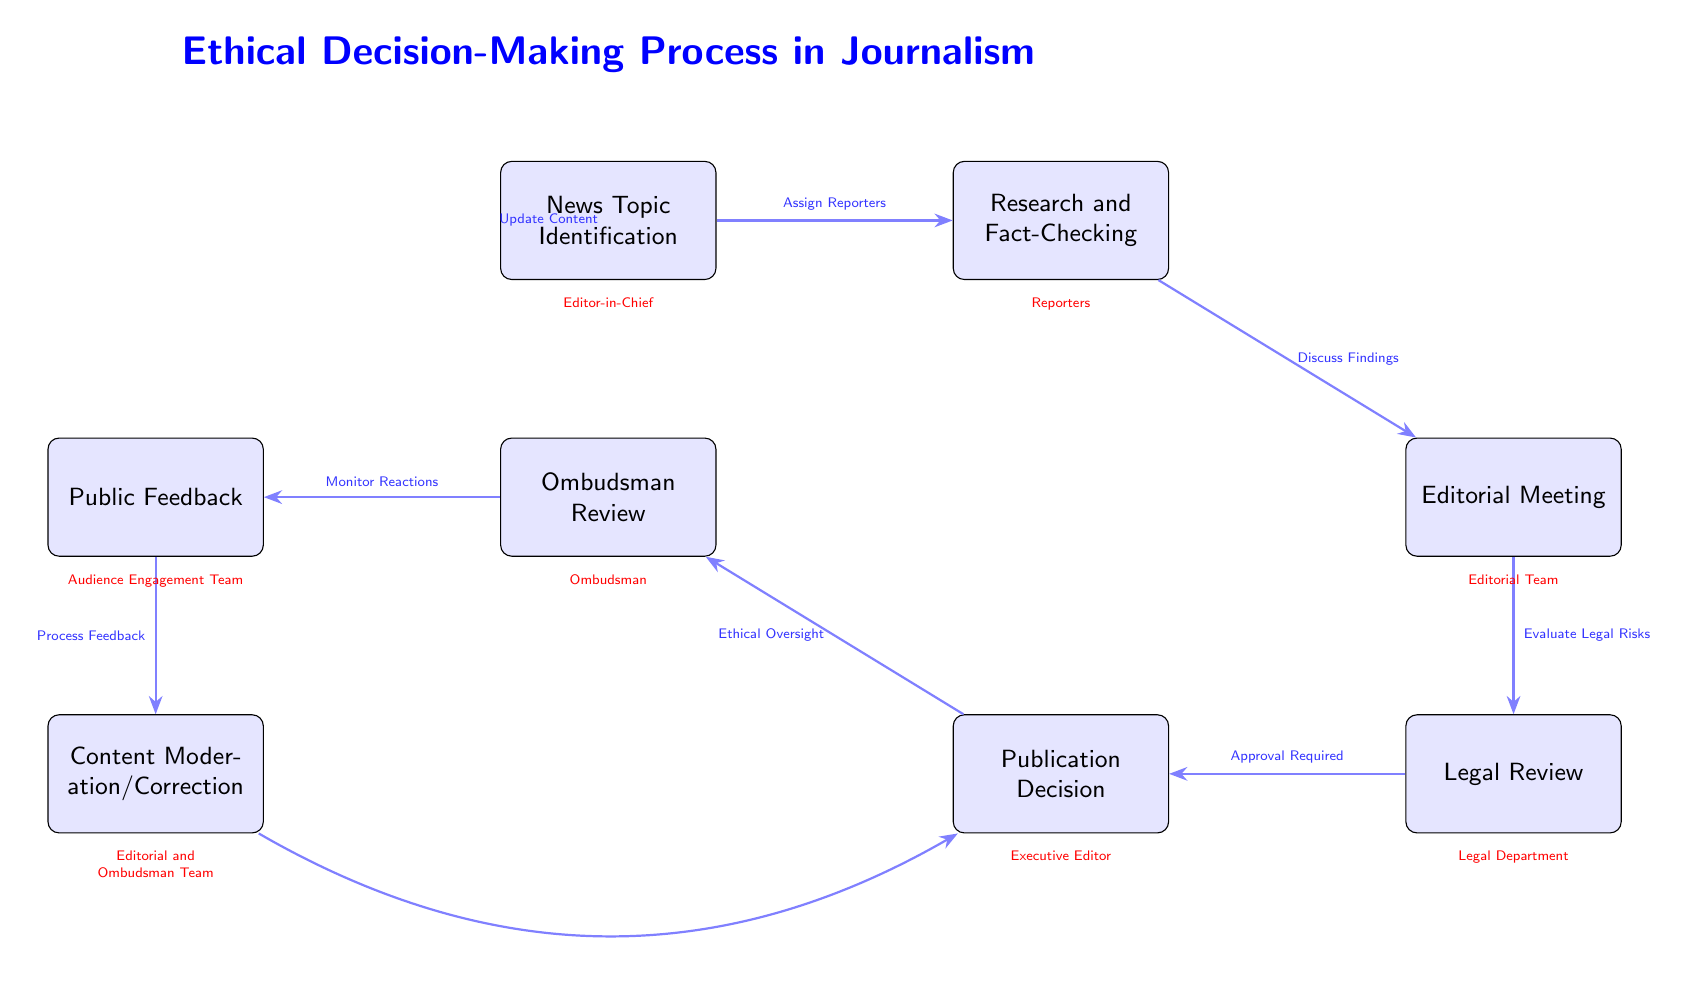What is the first step in the ethical decision-making process? The first step is represented by the node labeled "News Topic Identification." This is where the process begins in determining the subject matter to be reported.
Answer: News Topic Identification Who is responsible for the "Legal Review" step? The diagram indicates that the "Legal Department" is the responsible party for the "Legal Review" node, which evaluates any legal risks associated with the content.
Answer: Legal Department How many nodes are present in the diagram? If we count all the distinct boxes in the diagram, we find that there are a total of eight nodes, each representing a key step in the process.
Answer: 8 What follows after "Research and Fact-Checking"? According to the diagram, the arrow from "Research and Fact-Checking" points to "Editorial Meeting," indicating that the next step is this meeting where findings are discussed.
Answer: Editorial Meeting Which step involves "Ethical Oversight"? The node labeled "Ombudsman Review" deals with "Ethical Oversight". It is situated after the "Publication Decision" and involves oversight of ethical considerations.
Answer: Ombudsman Review What process is indicated to follow "Public Feedback"? The diagram shows an arrow leading from "Public Feedback" to "Content Moderation/Correction," indicating that this step occurs after processing public opinions and reactions.
Answer: Content Moderation/Correction What is the primary focus of the "Ombudsman" in this process? The "Ombudsman" serves primarily as a party responsible for the "Ombudsman Review," which focuses on ensuring ethical considerations are addressed within the journalism process.
Answer: Ombudsman Review Which step is immediately preceded by "Evaluate Legal Risks"? The step "Publication Decision" comes directly after "Evaluate Legal Risks," as indicated by the flow of the arrows in the diagram, signifying that legal risks need to be evaluated prior to publication.
Answer: Publication Decision What is the relationship between "Content Moderation/Correction" and "Publication Decision"? The diagram shows that "Content Moderation/Correction" is connected to "Publication Decision" with an arrow suggesting that updates to content can occur after feedback has been processed, indicating a feedback loop from moderation back to the publication phase.
Answer: Update Content 